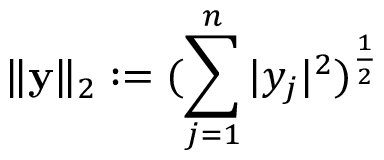Convert formula to latex. <formula><loc_0><loc_0><loc_500><loc_500>\| y \| _ { 2 } \colon = ( \sum _ { j = 1 } ^ { n } | y _ { j } | ^ { 2 } ) ^ { \frac { 1 } { 2 } }</formula> 